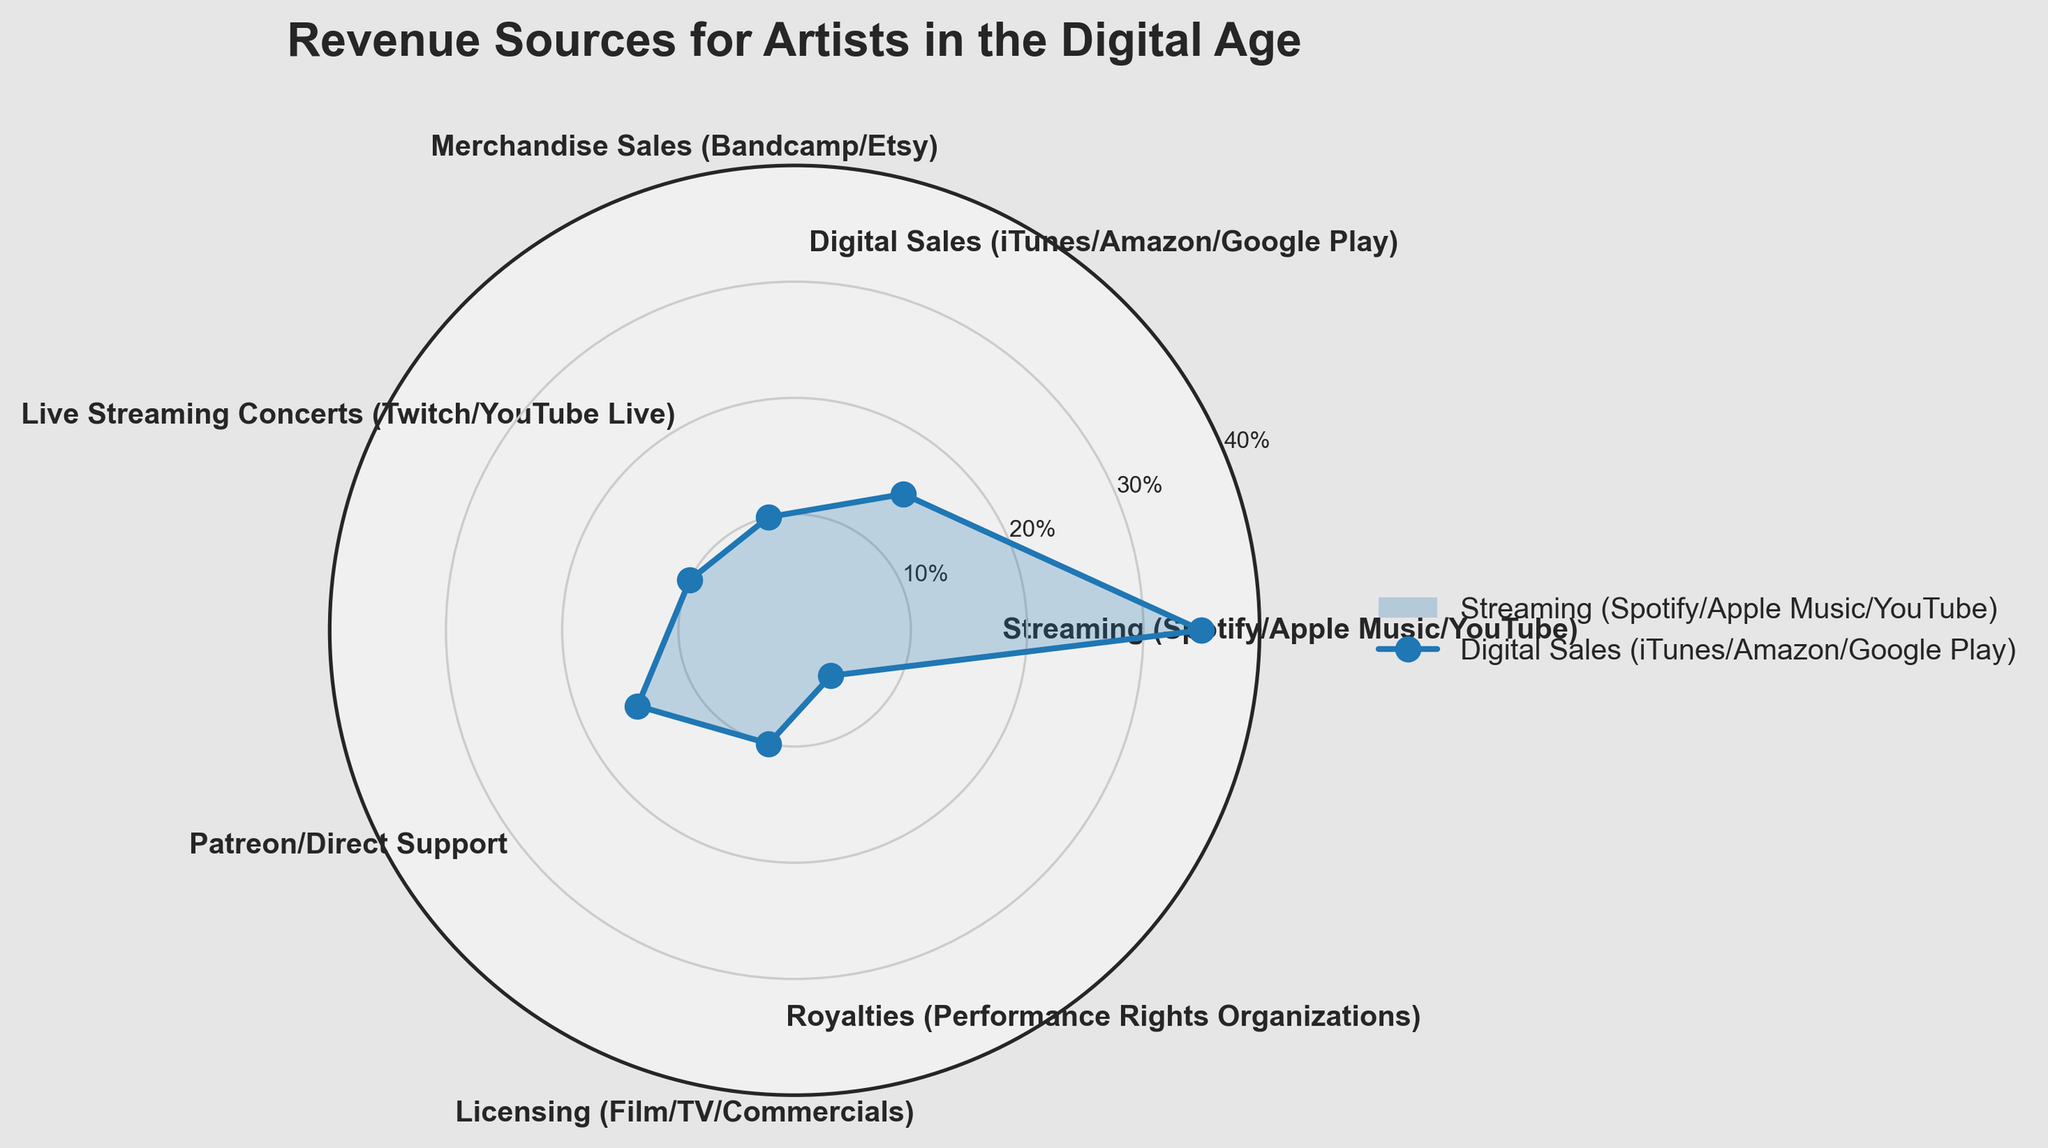What is the largest revenue source for artists shown in the chart? To find the largest revenue source, look for the category with the highest percentage. The chart shows "Streaming (Spotify/Apple Music/YouTube)" with 35%.
Answer: Streaming (Spotify/Apple Music/YouTube) Which revenue sources contribute equally to the artists' revenue? The chart shows that "Digital Sales (iTunes/Amazon/Google Play)" and "Patreon/Direct Support" both contribute 15%. Additionally, "Merchandise Sales (Bandcamp/Etsy)," "Live Streaming Concerts (Twitch/YouTube Live)," and "Licensing (Film/TV/Commercials)" each contribute 10%.
Answer: Digital Sales & Patreon/Direct Support; Merchandise Sales, Live Streaming Concerts & Licensing What percentage of revenue do Licensing (Film/TV/Commercials) and Royalties (Performance Rights Organizations) together contribute? Add the percentages for "Licensing (Film/TV/Commercials)" and "Royalties (Performance Rights Organizations)" which are 10% and 5% respectively. This results in 10% + 5% = 15%.
Answer: 15% Which revenue source is the smallest, and what is its percentage? The smallest revenue source has the lowest percentage. In the chart, "Royalties (Performance Rights Organizations)" is the smallest with 5%.
Answer: Royalties (Performance Rights Organizations), 5% How many revenue sources are depicted in the chart? Count the number of different categories listed in the chart. There are 7 categories.
Answer: 7 What is the combined percentage of revenue from Streaming (Spotify/Apple Music/YouTube) and Live Streaming Concerts (Twitch/YouTube Live)? Add the percentages for "Streaming (Spotify/Apple Music/YouTube)" which is 35% and "Live Streaming Concerts (Twitch/YouTube Live)" which is 10%. The combined percentage is 35% + 10% = 45%.
Answer: 45% Which categories generate an equal or greater percentage of revenue compared to Digital Sales? "Digital Sales (iTunes/Amazon/Google Play)" contributes 15%. Categories that generate an equal or greater percentage are "Streaming (Spotify/Apple Music/YouTube)" at 35% and "Patreon/Direct Support" at 15%.
Answer: Streaming & Patreon/Direct Support How does the percentage for Merchandise Sales compare to that for Digital Sales? "Merchandise Sales (Bandcamp/Etsy)" has a percentage of 10%, whereas "Digital Sales (iTunes/Amazon/Google Play)" has a percentage of 15%. Merchandise Sales has a lower percentage by 5%.
Answer: Lower by 5% 